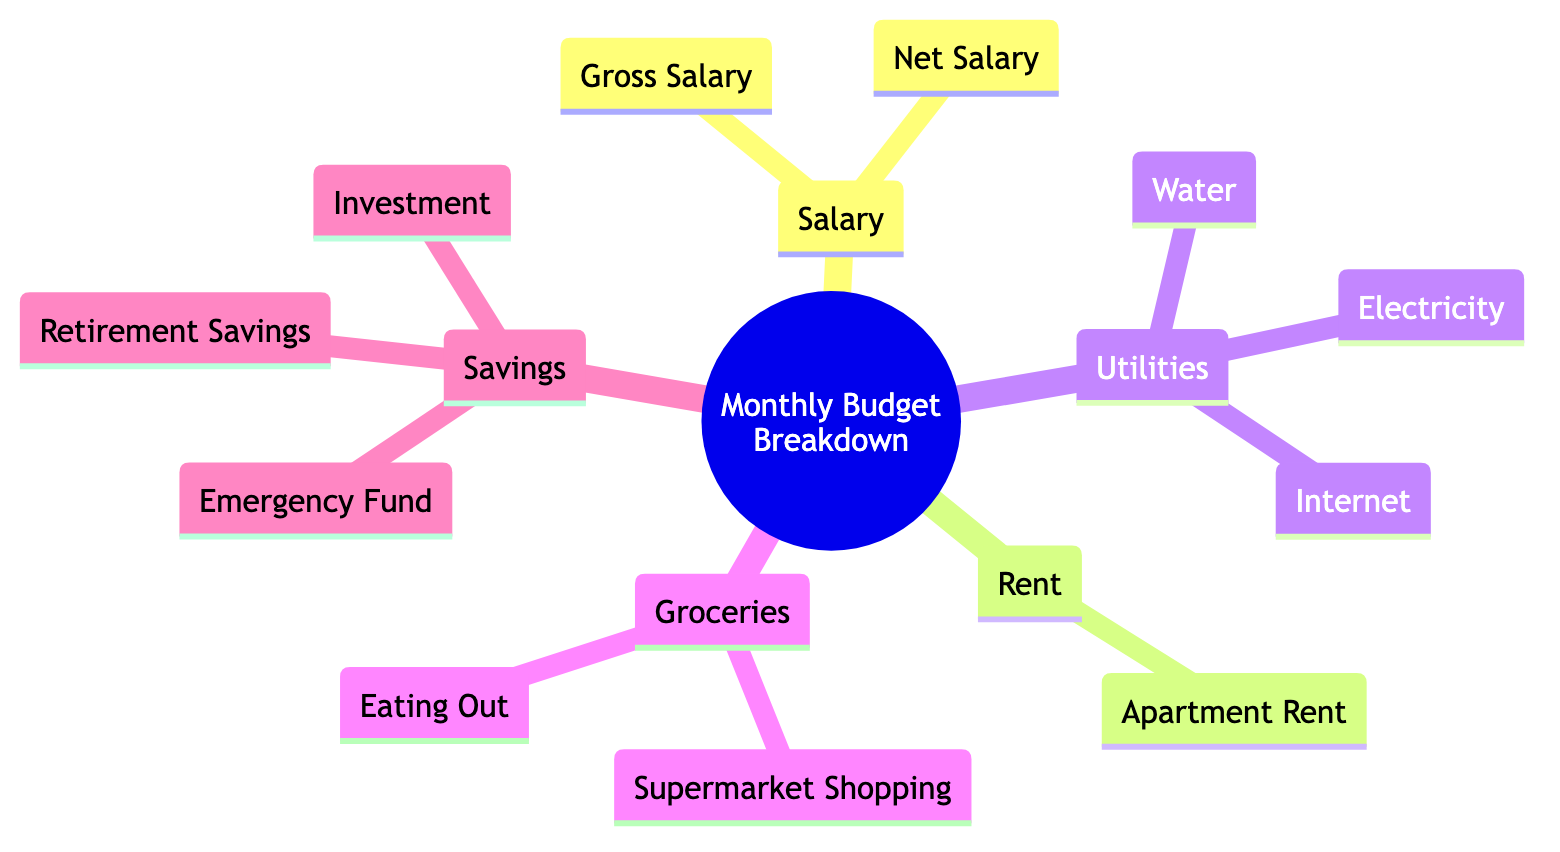What are the two categories under Savings? The diagram shows that the Savings category is broken down into three components: Emergency Fund, Retirement Savings, and Investment. The question specifically asks for two categories, so we can list any two among those three.
Answer: Emergency Fund, Retirement Savings How many subcategories are under Utilities? In the diagram, the Utilities category includes three distinct subcategories: Electricity, Water, and Internet. To find the answer, we can simply count these three elements.
Answer: 3 What comes directly under Rent? The Rent category contains a single component, which is Apartment Rent. There are no additional nodes or data points listed below Rent in the diagram.
Answer: Apartment Rent How many total components are in the diagram? To determine the total number of components, we can count all the primary categories and their respective subcomponents. This includes 5 main categories and their individual elements. The breakdown is as follows: 2 under Salary, 1 under Rent, 3 under Utilities, 2 under Groceries, and 3 under Savings. Adding these up gives a total of 12 components.
Answer: 12 Which category contains Eating Out? Eating Out is a subcomponent listed under the Groceries category based on the hierarchical structure of the diagram. This relationship can be confirmed by looking at the branches stemming from Groceries.
Answer: Groceries Which has more components: Rent or Utilities? To compare the two categories, we can count the components in each. Rent has 1 component while Utilities has 3 components (Electricity, Water, Internet). Thus, when we compare them, Utilities has more components.
Answer: Utilities What is the primary purpose of the Emergency Fund? The Emergency Fund is part of the Savings category and is generally used to cover unexpected expenses. While this information isn't explicitly stated in the diagram, it is widely understood within financial contexts.
Answer: Cover unexpected expenses What is the relationship between Salary and Savings? Salary is the source of income, which is essential for funding the Savings category. The connection illustrates that part of the net salary can be allocated towards savings, providing insight into personal finance management.
Answer: Source of funding 